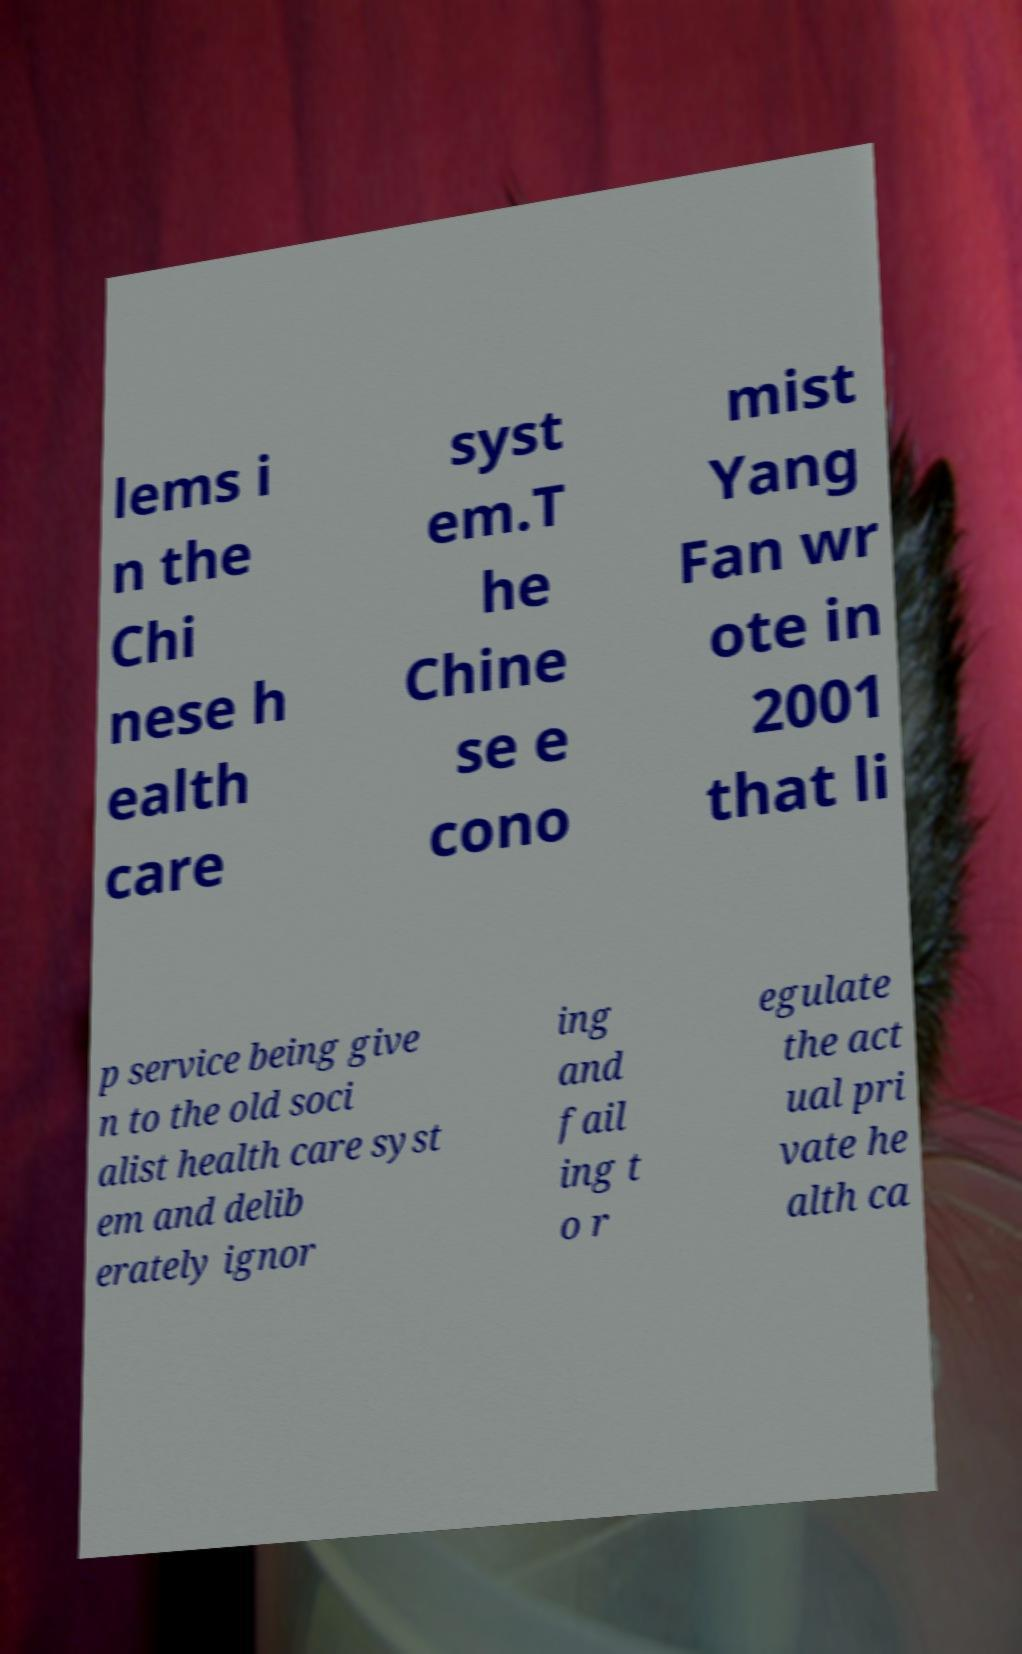Please identify and transcribe the text found in this image. lems i n the Chi nese h ealth care syst em.T he Chine se e cono mist Yang Fan wr ote in 2001 that li p service being give n to the old soci alist health care syst em and delib erately ignor ing and fail ing t o r egulate the act ual pri vate he alth ca 